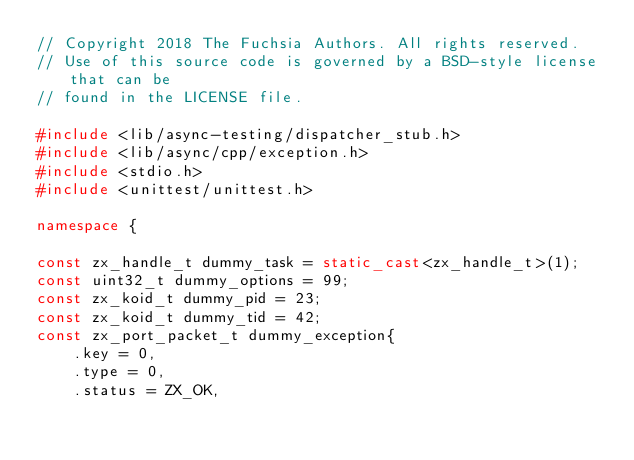<code> <loc_0><loc_0><loc_500><loc_500><_C++_>// Copyright 2018 The Fuchsia Authors. All rights reserved.
// Use of this source code is governed by a BSD-style license that can be
// found in the LICENSE file.

#include <lib/async-testing/dispatcher_stub.h>
#include <lib/async/cpp/exception.h>
#include <stdio.h>
#include <unittest/unittest.h>

namespace {

const zx_handle_t dummy_task = static_cast<zx_handle_t>(1);
const uint32_t dummy_options = 99;
const zx_koid_t dummy_pid = 23;
const zx_koid_t dummy_tid = 42;
const zx_port_packet_t dummy_exception{
    .key = 0,
    .type = 0,
    .status = ZX_OK,</code> 